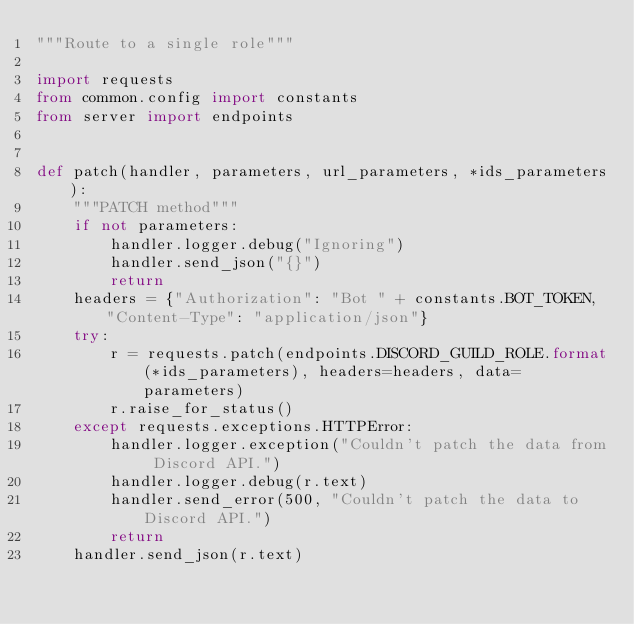<code> <loc_0><loc_0><loc_500><loc_500><_Python_>"""Route to a single role"""

import requests
from common.config import constants
from server import endpoints


def patch(handler, parameters, url_parameters, *ids_parameters):
    """PATCH method"""
    if not parameters:
        handler.logger.debug("Ignoring")
        handler.send_json("{}")
        return
    headers = {"Authorization": "Bot " + constants.BOT_TOKEN, "Content-Type": "application/json"}
    try:
        r = requests.patch(endpoints.DISCORD_GUILD_ROLE.format(*ids_parameters), headers=headers, data=parameters)
        r.raise_for_status()
    except requests.exceptions.HTTPError:
        handler.logger.exception("Couldn't patch the data from Discord API.")
        handler.logger.debug(r.text)
        handler.send_error(500, "Couldn't patch the data to Discord API.")
        return
    handler.send_json(r.text)

</code> 